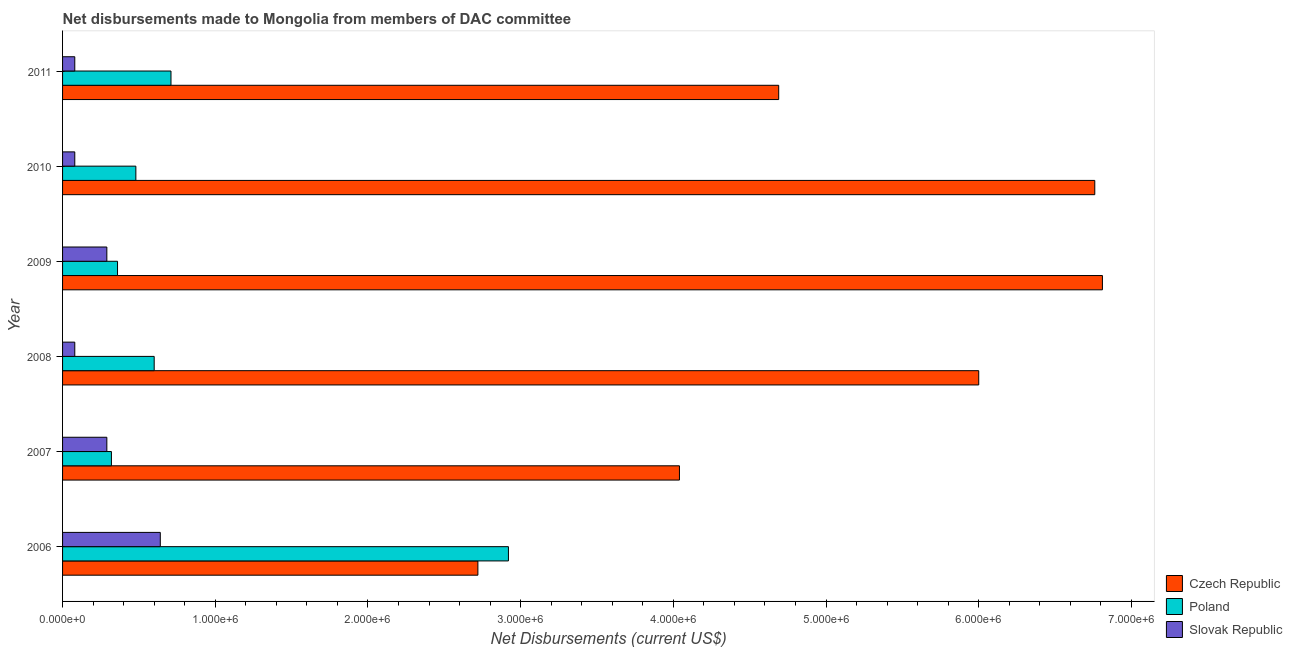How many different coloured bars are there?
Ensure brevity in your answer.  3. How many groups of bars are there?
Offer a very short reply. 6. Are the number of bars on each tick of the Y-axis equal?
Your response must be concise. Yes. How many bars are there on the 6th tick from the bottom?
Offer a terse response. 3. What is the net disbursements made by czech republic in 2007?
Your response must be concise. 4.04e+06. Across all years, what is the maximum net disbursements made by czech republic?
Give a very brief answer. 6.81e+06. Across all years, what is the minimum net disbursements made by czech republic?
Give a very brief answer. 2.72e+06. In which year was the net disbursements made by poland minimum?
Your answer should be compact. 2007. What is the total net disbursements made by czech republic in the graph?
Provide a short and direct response. 3.10e+07. What is the difference between the net disbursements made by czech republic in 2007 and that in 2011?
Your response must be concise. -6.50e+05. What is the difference between the net disbursements made by slovak republic in 2010 and the net disbursements made by poland in 2008?
Offer a very short reply. -5.20e+05. What is the average net disbursements made by czech republic per year?
Offer a very short reply. 5.17e+06. In the year 2006, what is the difference between the net disbursements made by czech republic and net disbursements made by slovak republic?
Offer a terse response. 2.08e+06. In how many years, is the net disbursements made by slovak republic greater than 2000000 US$?
Provide a short and direct response. 0. What is the ratio of the net disbursements made by czech republic in 2009 to that in 2011?
Offer a terse response. 1.45. Is the net disbursements made by slovak republic in 2007 less than that in 2011?
Provide a succinct answer. No. What is the difference between the highest and the lowest net disbursements made by poland?
Your answer should be very brief. 2.60e+06. In how many years, is the net disbursements made by poland greater than the average net disbursements made by poland taken over all years?
Offer a very short reply. 1. Is the sum of the net disbursements made by poland in 2008 and 2009 greater than the maximum net disbursements made by czech republic across all years?
Ensure brevity in your answer.  No. What does the 1st bar from the top in 2011 represents?
Offer a very short reply. Slovak Republic. What does the 3rd bar from the bottom in 2008 represents?
Provide a succinct answer. Slovak Republic. Are the values on the major ticks of X-axis written in scientific E-notation?
Offer a very short reply. Yes. Does the graph contain grids?
Your answer should be compact. No. Where does the legend appear in the graph?
Offer a very short reply. Bottom right. What is the title of the graph?
Ensure brevity in your answer.  Net disbursements made to Mongolia from members of DAC committee. What is the label or title of the X-axis?
Your answer should be very brief. Net Disbursements (current US$). What is the label or title of the Y-axis?
Offer a very short reply. Year. What is the Net Disbursements (current US$) in Czech Republic in 2006?
Your answer should be compact. 2.72e+06. What is the Net Disbursements (current US$) of Poland in 2006?
Offer a very short reply. 2.92e+06. What is the Net Disbursements (current US$) of Slovak Republic in 2006?
Provide a succinct answer. 6.40e+05. What is the Net Disbursements (current US$) of Czech Republic in 2007?
Keep it short and to the point. 4.04e+06. What is the Net Disbursements (current US$) of Poland in 2007?
Give a very brief answer. 3.20e+05. What is the Net Disbursements (current US$) of Slovak Republic in 2007?
Ensure brevity in your answer.  2.90e+05. What is the Net Disbursements (current US$) of Czech Republic in 2009?
Your answer should be compact. 6.81e+06. What is the Net Disbursements (current US$) of Poland in 2009?
Provide a succinct answer. 3.60e+05. What is the Net Disbursements (current US$) of Slovak Republic in 2009?
Ensure brevity in your answer.  2.90e+05. What is the Net Disbursements (current US$) of Czech Republic in 2010?
Ensure brevity in your answer.  6.76e+06. What is the Net Disbursements (current US$) in Slovak Republic in 2010?
Keep it short and to the point. 8.00e+04. What is the Net Disbursements (current US$) in Czech Republic in 2011?
Give a very brief answer. 4.69e+06. What is the Net Disbursements (current US$) in Poland in 2011?
Offer a very short reply. 7.10e+05. Across all years, what is the maximum Net Disbursements (current US$) of Czech Republic?
Offer a terse response. 6.81e+06. Across all years, what is the maximum Net Disbursements (current US$) of Poland?
Provide a short and direct response. 2.92e+06. Across all years, what is the maximum Net Disbursements (current US$) in Slovak Republic?
Keep it short and to the point. 6.40e+05. Across all years, what is the minimum Net Disbursements (current US$) in Czech Republic?
Give a very brief answer. 2.72e+06. What is the total Net Disbursements (current US$) in Czech Republic in the graph?
Give a very brief answer. 3.10e+07. What is the total Net Disbursements (current US$) in Poland in the graph?
Provide a short and direct response. 5.39e+06. What is the total Net Disbursements (current US$) in Slovak Republic in the graph?
Give a very brief answer. 1.46e+06. What is the difference between the Net Disbursements (current US$) of Czech Republic in 2006 and that in 2007?
Provide a short and direct response. -1.32e+06. What is the difference between the Net Disbursements (current US$) of Poland in 2006 and that in 2007?
Offer a very short reply. 2.60e+06. What is the difference between the Net Disbursements (current US$) in Slovak Republic in 2006 and that in 2007?
Offer a very short reply. 3.50e+05. What is the difference between the Net Disbursements (current US$) in Czech Republic in 2006 and that in 2008?
Provide a succinct answer. -3.28e+06. What is the difference between the Net Disbursements (current US$) of Poland in 2006 and that in 2008?
Make the answer very short. 2.32e+06. What is the difference between the Net Disbursements (current US$) of Slovak Republic in 2006 and that in 2008?
Make the answer very short. 5.60e+05. What is the difference between the Net Disbursements (current US$) of Czech Republic in 2006 and that in 2009?
Your answer should be very brief. -4.09e+06. What is the difference between the Net Disbursements (current US$) of Poland in 2006 and that in 2009?
Keep it short and to the point. 2.56e+06. What is the difference between the Net Disbursements (current US$) of Czech Republic in 2006 and that in 2010?
Ensure brevity in your answer.  -4.04e+06. What is the difference between the Net Disbursements (current US$) in Poland in 2006 and that in 2010?
Your response must be concise. 2.44e+06. What is the difference between the Net Disbursements (current US$) of Slovak Republic in 2006 and that in 2010?
Your answer should be very brief. 5.60e+05. What is the difference between the Net Disbursements (current US$) in Czech Republic in 2006 and that in 2011?
Your answer should be very brief. -1.97e+06. What is the difference between the Net Disbursements (current US$) of Poland in 2006 and that in 2011?
Provide a short and direct response. 2.21e+06. What is the difference between the Net Disbursements (current US$) in Slovak Republic in 2006 and that in 2011?
Provide a short and direct response. 5.60e+05. What is the difference between the Net Disbursements (current US$) in Czech Republic in 2007 and that in 2008?
Offer a very short reply. -1.96e+06. What is the difference between the Net Disbursements (current US$) of Poland in 2007 and that in 2008?
Make the answer very short. -2.80e+05. What is the difference between the Net Disbursements (current US$) of Czech Republic in 2007 and that in 2009?
Ensure brevity in your answer.  -2.77e+06. What is the difference between the Net Disbursements (current US$) in Slovak Republic in 2007 and that in 2009?
Your answer should be compact. 0. What is the difference between the Net Disbursements (current US$) in Czech Republic in 2007 and that in 2010?
Give a very brief answer. -2.72e+06. What is the difference between the Net Disbursements (current US$) of Slovak Republic in 2007 and that in 2010?
Ensure brevity in your answer.  2.10e+05. What is the difference between the Net Disbursements (current US$) in Czech Republic in 2007 and that in 2011?
Your response must be concise. -6.50e+05. What is the difference between the Net Disbursements (current US$) in Poland in 2007 and that in 2011?
Make the answer very short. -3.90e+05. What is the difference between the Net Disbursements (current US$) in Czech Republic in 2008 and that in 2009?
Keep it short and to the point. -8.10e+05. What is the difference between the Net Disbursements (current US$) of Czech Republic in 2008 and that in 2010?
Make the answer very short. -7.60e+05. What is the difference between the Net Disbursements (current US$) of Poland in 2008 and that in 2010?
Give a very brief answer. 1.20e+05. What is the difference between the Net Disbursements (current US$) in Slovak Republic in 2008 and that in 2010?
Provide a succinct answer. 0. What is the difference between the Net Disbursements (current US$) of Czech Republic in 2008 and that in 2011?
Offer a terse response. 1.31e+06. What is the difference between the Net Disbursements (current US$) of Poland in 2008 and that in 2011?
Your response must be concise. -1.10e+05. What is the difference between the Net Disbursements (current US$) of Czech Republic in 2009 and that in 2010?
Offer a terse response. 5.00e+04. What is the difference between the Net Disbursements (current US$) in Czech Republic in 2009 and that in 2011?
Give a very brief answer. 2.12e+06. What is the difference between the Net Disbursements (current US$) in Poland in 2009 and that in 2011?
Provide a succinct answer. -3.50e+05. What is the difference between the Net Disbursements (current US$) in Czech Republic in 2010 and that in 2011?
Offer a very short reply. 2.07e+06. What is the difference between the Net Disbursements (current US$) in Poland in 2010 and that in 2011?
Make the answer very short. -2.30e+05. What is the difference between the Net Disbursements (current US$) in Czech Republic in 2006 and the Net Disbursements (current US$) in Poland in 2007?
Provide a succinct answer. 2.40e+06. What is the difference between the Net Disbursements (current US$) in Czech Republic in 2006 and the Net Disbursements (current US$) in Slovak Republic in 2007?
Your response must be concise. 2.43e+06. What is the difference between the Net Disbursements (current US$) of Poland in 2006 and the Net Disbursements (current US$) of Slovak Republic in 2007?
Provide a succinct answer. 2.63e+06. What is the difference between the Net Disbursements (current US$) in Czech Republic in 2006 and the Net Disbursements (current US$) in Poland in 2008?
Offer a terse response. 2.12e+06. What is the difference between the Net Disbursements (current US$) in Czech Republic in 2006 and the Net Disbursements (current US$) in Slovak Republic in 2008?
Provide a succinct answer. 2.64e+06. What is the difference between the Net Disbursements (current US$) of Poland in 2006 and the Net Disbursements (current US$) of Slovak Republic in 2008?
Provide a short and direct response. 2.84e+06. What is the difference between the Net Disbursements (current US$) in Czech Republic in 2006 and the Net Disbursements (current US$) in Poland in 2009?
Ensure brevity in your answer.  2.36e+06. What is the difference between the Net Disbursements (current US$) of Czech Republic in 2006 and the Net Disbursements (current US$) of Slovak Republic in 2009?
Provide a succinct answer. 2.43e+06. What is the difference between the Net Disbursements (current US$) in Poland in 2006 and the Net Disbursements (current US$) in Slovak Republic in 2009?
Give a very brief answer. 2.63e+06. What is the difference between the Net Disbursements (current US$) in Czech Republic in 2006 and the Net Disbursements (current US$) in Poland in 2010?
Give a very brief answer. 2.24e+06. What is the difference between the Net Disbursements (current US$) in Czech Republic in 2006 and the Net Disbursements (current US$) in Slovak Republic in 2010?
Offer a terse response. 2.64e+06. What is the difference between the Net Disbursements (current US$) in Poland in 2006 and the Net Disbursements (current US$) in Slovak Republic in 2010?
Provide a short and direct response. 2.84e+06. What is the difference between the Net Disbursements (current US$) of Czech Republic in 2006 and the Net Disbursements (current US$) of Poland in 2011?
Offer a very short reply. 2.01e+06. What is the difference between the Net Disbursements (current US$) in Czech Republic in 2006 and the Net Disbursements (current US$) in Slovak Republic in 2011?
Provide a short and direct response. 2.64e+06. What is the difference between the Net Disbursements (current US$) of Poland in 2006 and the Net Disbursements (current US$) of Slovak Republic in 2011?
Keep it short and to the point. 2.84e+06. What is the difference between the Net Disbursements (current US$) in Czech Republic in 2007 and the Net Disbursements (current US$) in Poland in 2008?
Offer a terse response. 3.44e+06. What is the difference between the Net Disbursements (current US$) in Czech Republic in 2007 and the Net Disbursements (current US$) in Slovak Republic in 2008?
Your answer should be very brief. 3.96e+06. What is the difference between the Net Disbursements (current US$) of Czech Republic in 2007 and the Net Disbursements (current US$) of Poland in 2009?
Offer a very short reply. 3.68e+06. What is the difference between the Net Disbursements (current US$) in Czech Republic in 2007 and the Net Disbursements (current US$) in Slovak Republic in 2009?
Provide a succinct answer. 3.75e+06. What is the difference between the Net Disbursements (current US$) of Czech Republic in 2007 and the Net Disbursements (current US$) of Poland in 2010?
Your response must be concise. 3.56e+06. What is the difference between the Net Disbursements (current US$) in Czech Republic in 2007 and the Net Disbursements (current US$) in Slovak Republic in 2010?
Ensure brevity in your answer.  3.96e+06. What is the difference between the Net Disbursements (current US$) of Czech Republic in 2007 and the Net Disbursements (current US$) of Poland in 2011?
Give a very brief answer. 3.33e+06. What is the difference between the Net Disbursements (current US$) in Czech Republic in 2007 and the Net Disbursements (current US$) in Slovak Republic in 2011?
Your answer should be very brief. 3.96e+06. What is the difference between the Net Disbursements (current US$) in Poland in 2007 and the Net Disbursements (current US$) in Slovak Republic in 2011?
Give a very brief answer. 2.40e+05. What is the difference between the Net Disbursements (current US$) in Czech Republic in 2008 and the Net Disbursements (current US$) in Poland in 2009?
Offer a very short reply. 5.64e+06. What is the difference between the Net Disbursements (current US$) of Czech Republic in 2008 and the Net Disbursements (current US$) of Slovak Republic in 2009?
Make the answer very short. 5.71e+06. What is the difference between the Net Disbursements (current US$) of Poland in 2008 and the Net Disbursements (current US$) of Slovak Republic in 2009?
Provide a succinct answer. 3.10e+05. What is the difference between the Net Disbursements (current US$) in Czech Republic in 2008 and the Net Disbursements (current US$) in Poland in 2010?
Give a very brief answer. 5.52e+06. What is the difference between the Net Disbursements (current US$) in Czech Republic in 2008 and the Net Disbursements (current US$) in Slovak Republic in 2010?
Your answer should be compact. 5.92e+06. What is the difference between the Net Disbursements (current US$) of Poland in 2008 and the Net Disbursements (current US$) of Slovak Republic in 2010?
Your response must be concise. 5.20e+05. What is the difference between the Net Disbursements (current US$) of Czech Republic in 2008 and the Net Disbursements (current US$) of Poland in 2011?
Your answer should be very brief. 5.29e+06. What is the difference between the Net Disbursements (current US$) of Czech Republic in 2008 and the Net Disbursements (current US$) of Slovak Republic in 2011?
Offer a very short reply. 5.92e+06. What is the difference between the Net Disbursements (current US$) of Poland in 2008 and the Net Disbursements (current US$) of Slovak Republic in 2011?
Your answer should be compact. 5.20e+05. What is the difference between the Net Disbursements (current US$) in Czech Republic in 2009 and the Net Disbursements (current US$) in Poland in 2010?
Give a very brief answer. 6.33e+06. What is the difference between the Net Disbursements (current US$) in Czech Republic in 2009 and the Net Disbursements (current US$) in Slovak Republic in 2010?
Your response must be concise. 6.73e+06. What is the difference between the Net Disbursements (current US$) in Poland in 2009 and the Net Disbursements (current US$) in Slovak Republic in 2010?
Offer a very short reply. 2.80e+05. What is the difference between the Net Disbursements (current US$) in Czech Republic in 2009 and the Net Disbursements (current US$) in Poland in 2011?
Offer a very short reply. 6.10e+06. What is the difference between the Net Disbursements (current US$) of Czech Republic in 2009 and the Net Disbursements (current US$) of Slovak Republic in 2011?
Your answer should be compact. 6.73e+06. What is the difference between the Net Disbursements (current US$) of Poland in 2009 and the Net Disbursements (current US$) of Slovak Republic in 2011?
Your answer should be very brief. 2.80e+05. What is the difference between the Net Disbursements (current US$) of Czech Republic in 2010 and the Net Disbursements (current US$) of Poland in 2011?
Offer a terse response. 6.05e+06. What is the difference between the Net Disbursements (current US$) of Czech Republic in 2010 and the Net Disbursements (current US$) of Slovak Republic in 2011?
Ensure brevity in your answer.  6.68e+06. What is the average Net Disbursements (current US$) in Czech Republic per year?
Your response must be concise. 5.17e+06. What is the average Net Disbursements (current US$) in Poland per year?
Your answer should be compact. 8.98e+05. What is the average Net Disbursements (current US$) of Slovak Republic per year?
Your answer should be compact. 2.43e+05. In the year 2006, what is the difference between the Net Disbursements (current US$) of Czech Republic and Net Disbursements (current US$) of Slovak Republic?
Make the answer very short. 2.08e+06. In the year 2006, what is the difference between the Net Disbursements (current US$) in Poland and Net Disbursements (current US$) in Slovak Republic?
Your response must be concise. 2.28e+06. In the year 2007, what is the difference between the Net Disbursements (current US$) of Czech Republic and Net Disbursements (current US$) of Poland?
Your response must be concise. 3.72e+06. In the year 2007, what is the difference between the Net Disbursements (current US$) of Czech Republic and Net Disbursements (current US$) of Slovak Republic?
Ensure brevity in your answer.  3.75e+06. In the year 2007, what is the difference between the Net Disbursements (current US$) of Poland and Net Disbursements (current US$) of Slovak Republic?
Provide a succinct answer. 3.00e+04. In the year 2008, what is the difference between the Net Disbursements (current US$) in Czech Republic and Net Disbursements (current US$) in Poland?
Give a very brief answer. 5.40e+06. In the year 2008, what is the difference between the Net Disbursements (current US$) of Czech Republic and Net Disbursements (current US$) of Slovak Republic?
Make the answer very short. 5.92e+06. In the year 2008, what is the difference between the Net Disbursements (current US$) in Poland and Net Disbursements (current US$) in Slovak Republic?
Make the answer very short. 5.20e+05. In the year 2009, what is the difference between the Net Disbursements (current US$) in Czech Republic and Net Disbursements (current US$) in Poland?
Your answer should be very brief. 6.45e+06. In the year 2009, what is the difference between the Net Disbursements (current US$) in Czech Republic and Net Disbursements (current US$) in Slovak Republic?
Ensure brevity in your answer.  6.52e+06. In the year 2010, what is the difference between the Net Disbursements (current US$) of Czech Republic and Net Disbursements (current US$) of Poland?
Your response must be concise. 6.28e+06. In the year 2010, what is the difference between the Net Disbursements (current US$) in Czech Republic and Net Disbursements (current US$) in Slovak Republic?
Your answer should be very brief. 6.68e+06. In the year 2011, what is the difference between the Net Disbursements (current US$) in Czech Republic and Net Disbursements (current US$) in Poland?
Provide a short and direct response. 3.98e+06. In the year 2011, what is the difference between the Net Disbursements (current US$) of Czech Republic and Net Disbursements (current US$) of Slovak Republic?
Offer a very short reply. 4.61e+06. In the year 2011, what is the difference between the Net Disbursements (current US$) of Poland and Net Disbursements (current US$) of Slovak Republic?
Your answer should be very brief. 6.30e+05. What is the ratio of the Net Disbursements (current US$) in Czech Republic in 2006 to that in 2007?
Your response must be concise. 0.67. What is the ratio of the Net Disbursements (current US$) in Poland in 2006 to that in 2007?
Give a very brief answer. 9.12. What is the ratio of the Net Disbursements (current US$) in Slovak Republic in 2006 to that in 2007?
Your answer should be very brief. 2.21. What is the ratio of the Net Disbursements (current US$) of Czech Republic in 2006 to that in 2008?
Give a very brief answer. 0.45. What is the ratio of the Net Disbursements (current US$) of Poland in 2006 to that in 2008?
Keep it short and to the point. 4.87. What is the ratio of the Net Disbursements (current US$) in Slovak Republic in 2006 to that in 2008?
Offer a terse response. 8. What is the ratio of the Net Disbursements (current US$) of Czech Republic in 2006 to that in 2009?
Make the answer very short. 0.4. What is the ratio of the Net Disbursements (current US$) in Poland in 2006 to that in 2009?
Your response must be concise. 8.11. What is the ratio of the Net Disbursements (current US$) in Slovak Republic in 2006 to that in 2009?
Give a very brief answer. 2.21. What is the ratio of the Net Disbursements (current US$) in Czech Republic in 2006 to that in 2010?
Provide a short and direct response. 0.4. What is the ratio of the Net Disbursements (current US$) in Poland in 2006 to that in 2010?
Your answer should be very brief. 6.08. What is the ratio of the Net Disbursements (current US$) in Czech Republic in 2006 to that in 2011?
Offer a very short reply. 0.58. What is the ratio of the Net Disbursements (current US$) of Poland in 2006 to that in 2011?
Your answer should be compact. 4.11. What is the ratio of the Net Disbursements (current US$) in Czech Republic in 2007 to that in 2008?
Provide a succinct answer. 0.67. What is the ratio of the Net Disbursements (current US$) in Poland in 2007 to that in 2008?
Provide a short and direct response. 0.53. What is the ratio of the Net Disbursements (current US$) of Slovak Republic in 2007 to that in 2008?
Your answer should be compact. 3.62. What is the ratio of the Net Disbursements (current US$) in Czech Republic in 2007 to that in 2009?
Offer a very short reply. 0.59. What is the ratio of the Net Disbursements (current US$) of Czech Republic in 2007 to that in 2010?
Make the answer very short. 0.6. What is the ratio of the Net Disbursements (current US$) of Slovak Republic in 2007 to that in 2010?
Provide a succinct answer. 3.62. What is the ratio of the Net Disbursements (current US$) in Czech Republic in 2007 to that in 2011?
Offer a very short reply. 0.86. What is the ratio of the Net Disbursements (current US$) in Poland in 2007 to that in 2011?
Make the answer very short. 0.45. What is the ratio of the Net Disbursements (current US$) of Slovak Republic in 2007 to that in 2011?
Keep it short and to the point. 3.62. What is the ratio of the Net Disbursements (current US$) of Czech Republic in 2008 to that in 2009?
Your answer should be very brief. 0.88. What is the ratio of the Net Disbursements (current US$) in Slovak Republic in 2008 to that in 2009?
Your answer should be compact. 0.28. What is the ratio of the Net Disbursements (current US$) in Czech Republic in 2008 to that in 2010?
Your response must be concise. 0.89. What is the ratio of the Net Disbursements (current US$) in Poland in 2008 to that in 2010?
Keep it short and to the point. 1.25. What is the ratio of the Net Disbursements (current US$) in Czech Republic in 2008 to that in 2011?
Your answer should be very brief. 1.28. What is the ratio of the Net Disbursements (current US$) of Poland in 2008 to that in 2011?
Your answer should be very brief. 0.85. What is the ratio of the Net Disbursements (current US$) of Slovak Republic in 2008 to that in 2011?
Provide a short and direct response. 1. What is the ratio of the Net Disbursements (current US$) of Czech Republic in 2009 to that in 2010?
Offer a very short reply. 1.01. What is the ratio of the Net Disbursements (current US$) of Poland in 2009 to that in 2010?
Offer a terse response. 0.75. What is the ratio of the Net Disbursements (current US$) of Slovak Republic in 2009 to that in 2010?
Offer a terse response. 3.62. What is the ratio of the Net Disbursements (current US$) in Czech Republic in 2009 to that in 2011?
Give a very brief answer. 1.45. What is the ratio of the Net Disbursements (current US$) in Poland in 2009 to that in 2011?
Offer a very short reply. 0.51. What is the ratio of the Net Disbursements (current US$) in Slovak Republic in 2009 to that in 2011?
Give a very brief answer. 3.62. What is the ratio of the Net Disbursements (current US$) of Czech Republic in 2010 to that in 2011?
Provide a short and direct response. 1.44. What is the ratio of the Net Disbursements (current US$) in Poland in 2010 to that in 2011?
Keep it short and to the point. 0.68. What is the ratio of the Net Disbursements (current US$) of Slovak Republic in 2010 to that in 2011?
Your response must be concise. 1. What is the difference between the highest and the second highest Net Disbursements (current US$) of Czech Republic?
Your response must be concise. 5.00e+04. What is the difference between the highest and the second highest Net Disbursements (current US$) of Poland?
Your answer should be compact. 2.21e+06. What is the difference between the highest and the second highest Net Disbursements (current US$) in Slovak Republic?
Keep it short and to the point. 3.50e+05. What is the difference between the highest and the lowest Net Disbursements (current US$) of Czech Republic?
Provide a short and direct response. 4.09e+06. What is the difference between the highest and the lowest Net Disbursements (current US$) of Poland?
Offer a terse response. 2.60e+06. What is the difference between the highest and the lowest Net Disbursements (current US$) in Slovak Republic?
Offer a terse response. 5.60e+05. 